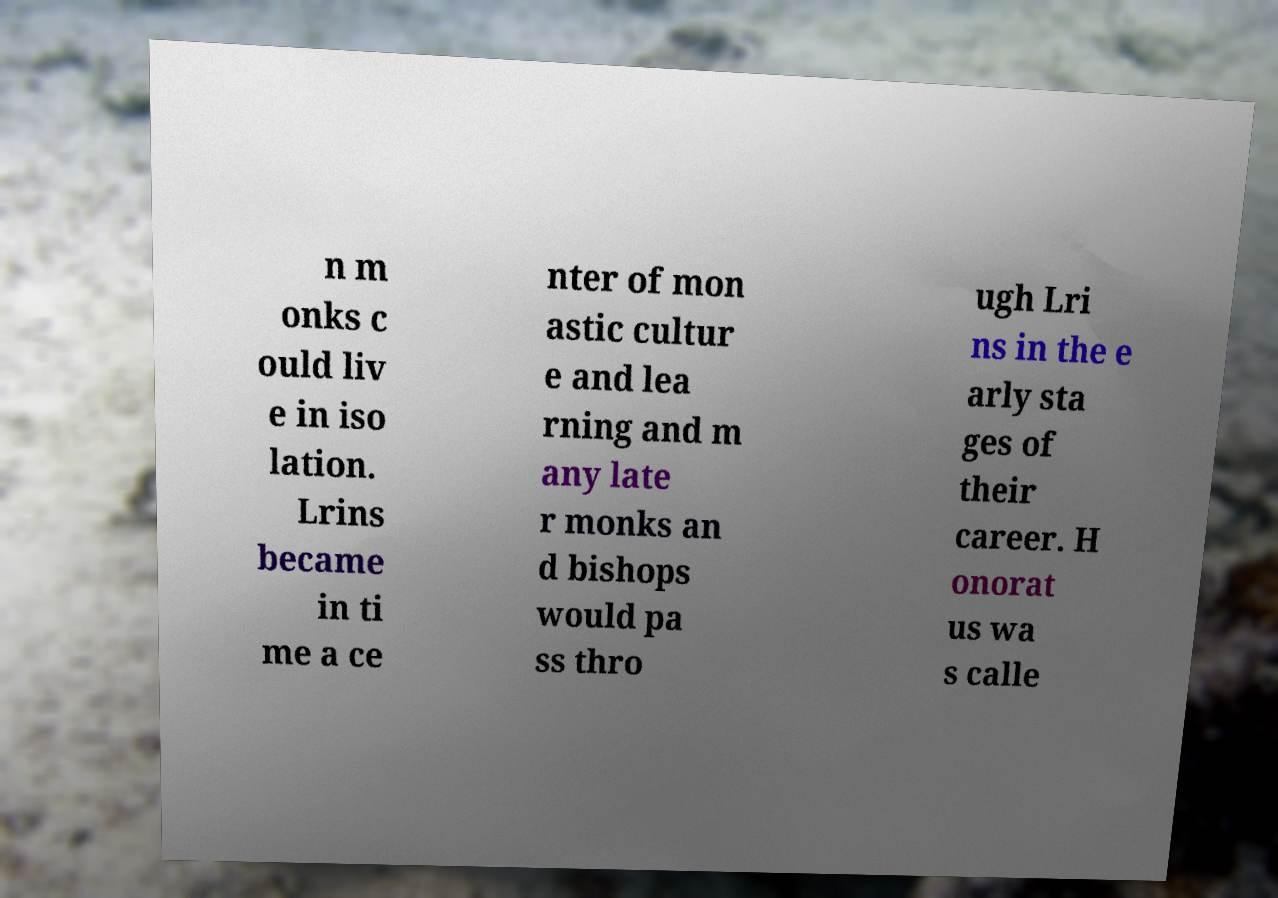Please identify and transcribe the text found in this image. n m onks c ould liv e in iso lation. Lrins became in ti me a ce nter of mon astic cultur e and lea rning and m any late r monks an d bishops would pa ss thro ugh Lri ns in the e arly sta ges of their career. H onorat us wa s calle 